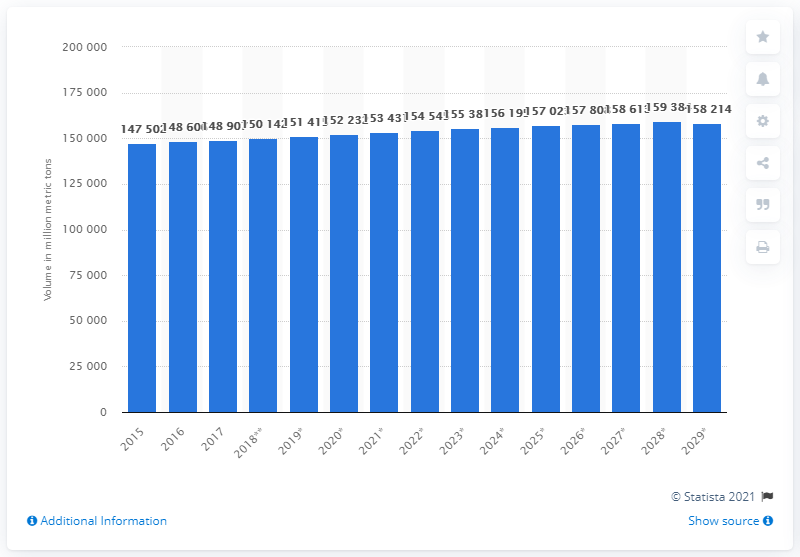Mention a couple of crucial points in this snapshot. The estimated production volume of milk in 2029 is 158,214. 